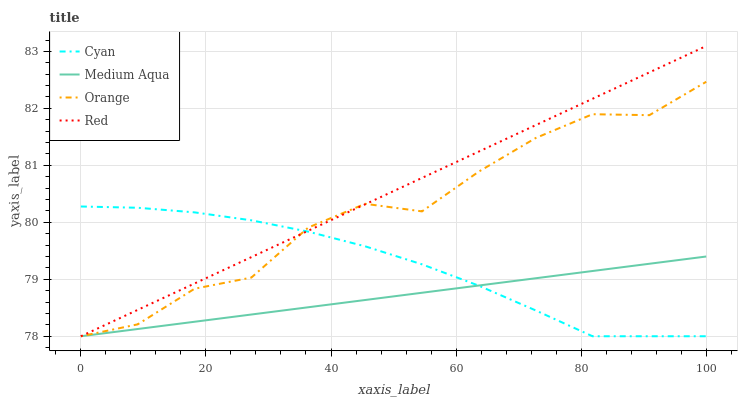Does Medium Aqua have the minimum area under the curve?
Answer yes or no. Yes. Does Red have the maximum area under the curve?
Answer yes or no. Yes. Does Cyan have the minimum area under the curve?
Answer yes or no. No. Does Cyan have the maximum area under the curve?
Answer yes or no. No. Is Red the smoothest?
Answer yes or no. Yes. Is Orange the roughest?
Answer yes or no. Yes. Is Cyan the smoothest?
Answer yes or no. No. Is Cyan the roughest?
Answer yes or no. No. Does Orange have the lowest value?
Answer yes or no. Yes. Does Red have the highest value?
Answer yes or no. Yes. Does Cyan have the highest value?
Answer yes or no. No. Does Orange intersect Medium Aqua?
Answer yes or no. Yes. Is Orange less than Medium Aqua?
Answer yes or no. No. Is Orange greater than Medium Aqua?
Answer yes or no. No. 